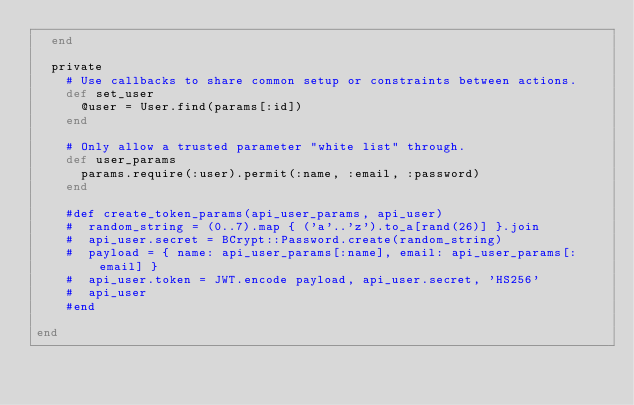<code> <loc_0><loc_0><loc_500><loc_500><_Ruby_>  end

  private
    # Use callbacks to share common setup or constraints between actions.
    def set_user
      @user = User.find(params[:id])
    end

    # Only allow a trusted parameter "white list" through.
    def user_params
      params.require(:user).permit(:name, :email, :password)
    end

    #def create_token_params(api_user_params, api_user)
    #  random_string = (0..7).map { ('a'..'z').to_a[rand(26)] }.join
    #  api_user.secret = BCrypt::Password.create(random_string)
    #  payload = { name: api_user_params[:name], email: api_user_params[:email] }
    #  api_user.token = JWT.encode payload, api_user.secret, 'HS256'
    #  api_user
    #end
    
end
</code> 